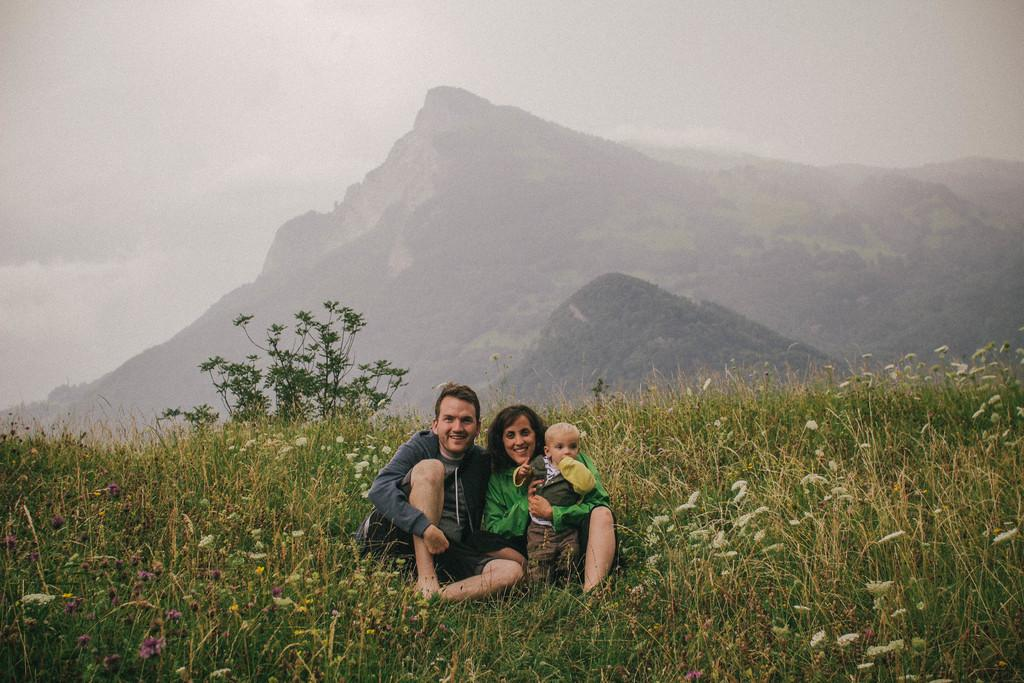What is happening in the center of the image? There are people sitting in the center of the image. Where are the people sitting? The people are sitting on a grassland. What can be seen in the background of the image? There is greenery and the sky visible in the background of the image. Are there any rabbits eating breakfast under an umbrella in the image? There are no rabbits or umbrellas present in the image. 